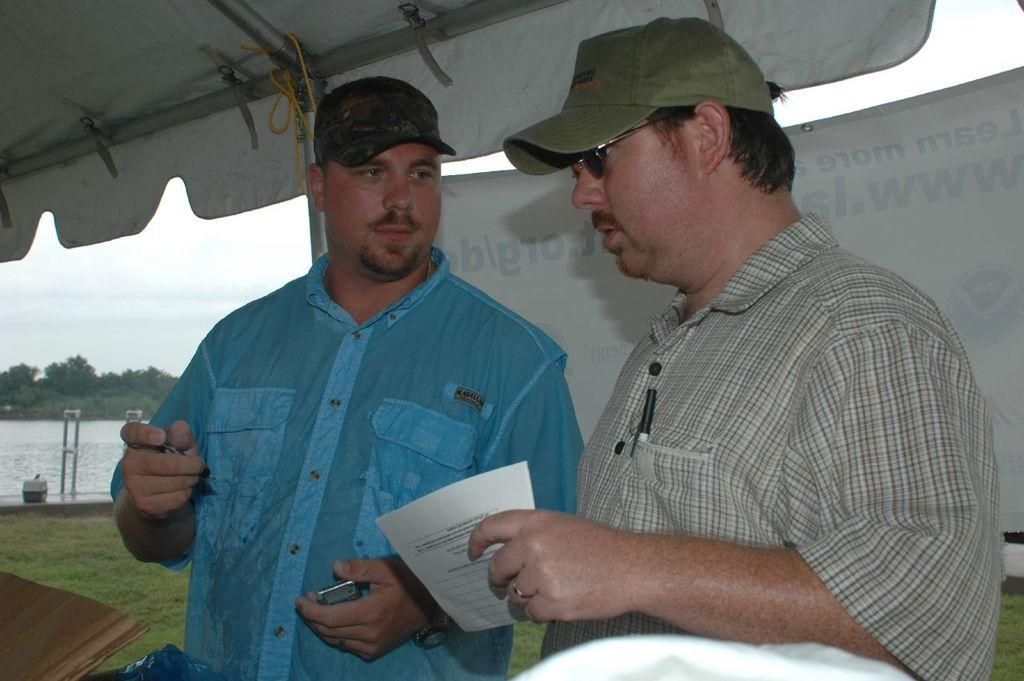What are the persons in the center of the image doing? The persons in the center of the image are holding a paper. What can be seen in the background of the image? In the background of the image, there is a banner, a tent, water, grass, trees, and the sky with clouds. How many elements can be identified in the background of the image? There are seven elements in the background of the image: a banner, a tent, water, grass, trees, the sky, and clouds. How many geese are swimming in the water in the image? There are no geese visible in the image; only water is present in the background. Can you tell me where the drawer is located in the image? There is no drawer present in the image. 